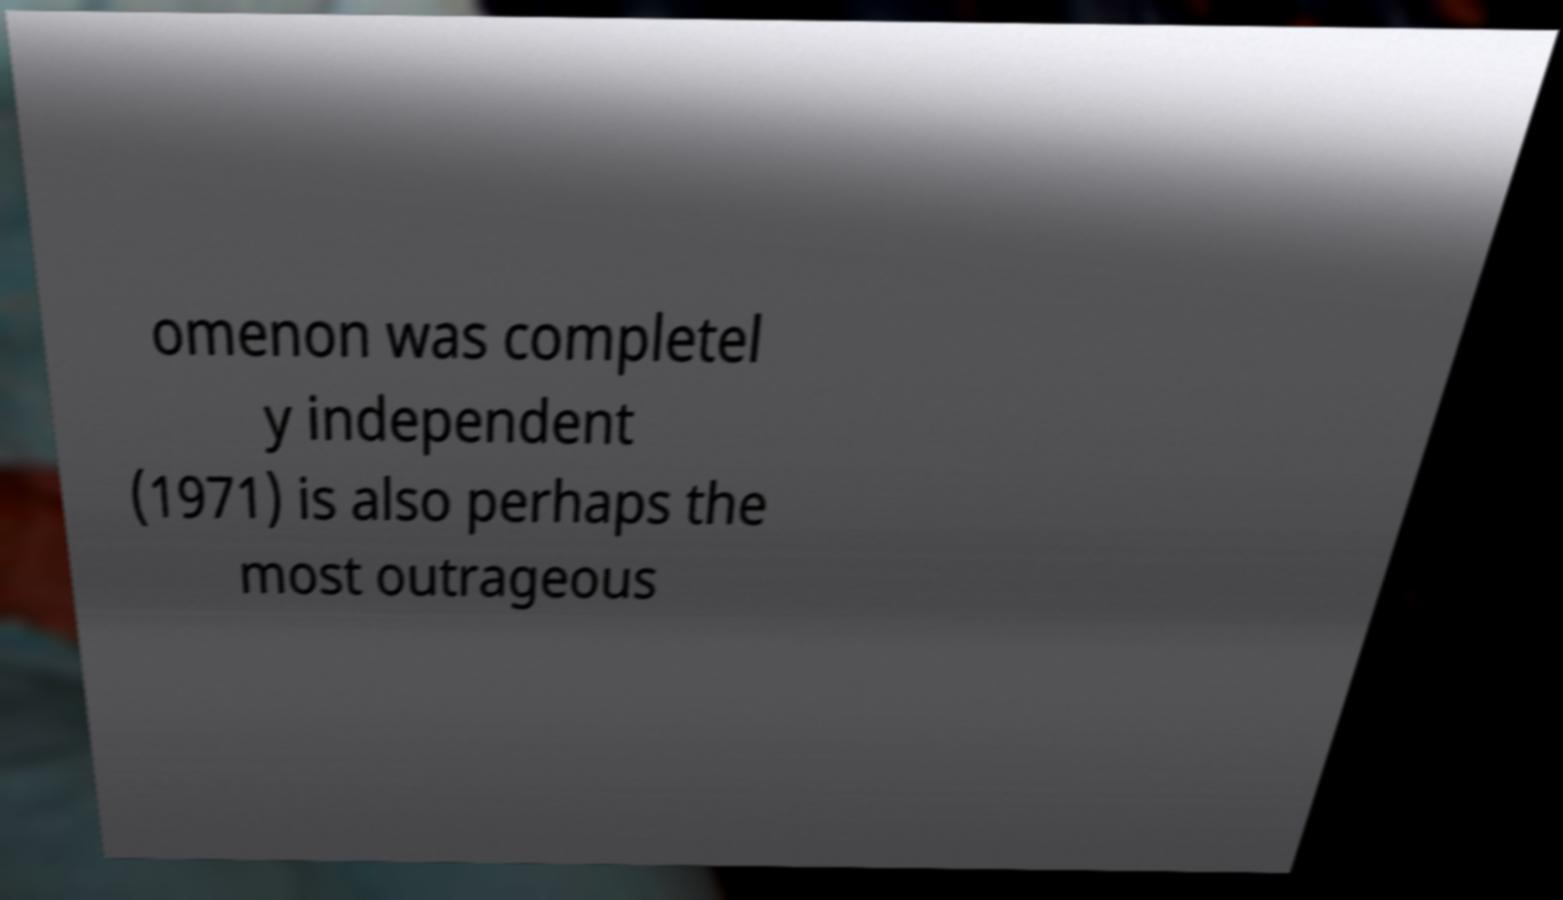Could you extract and type out the text from this image? omenon was completel y independent (1971) is also perhaps the most outrageous 